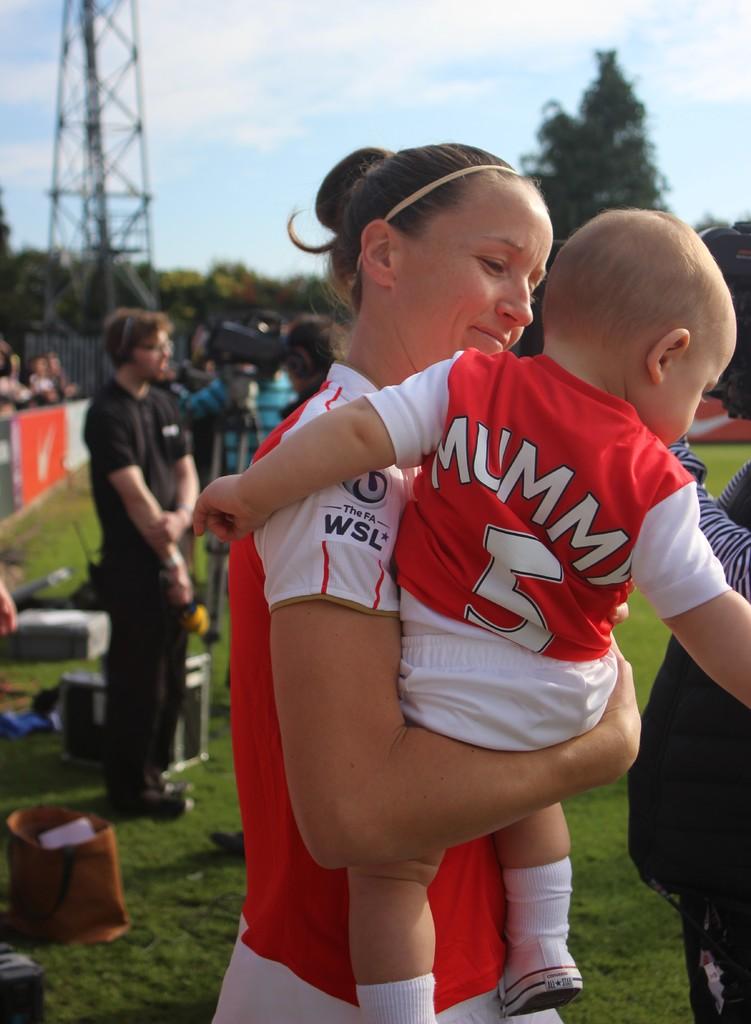What number is the baby wearing?
Your answer should be compact. 5. 